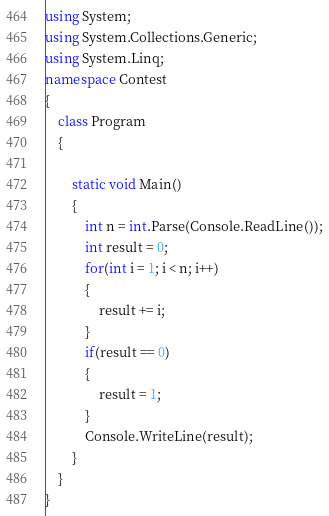<code> <loc_0><loc_0><loc_500><loc_500><_C#_>using System;
using System.Collections.Generic;
using System.Linq;
namespace Contest
{
    class Program
    {

        static void Main()
        {
            int n = int.Parse(Console.ReadLine());
            int result = 0;
            for(int i = 1; i < n; i++)
            {
                result += i;
            }
            if(result == 0)
            {
                result = 1;
            }
            Console.WriteLine(result);
        }
    }
}
</code> 